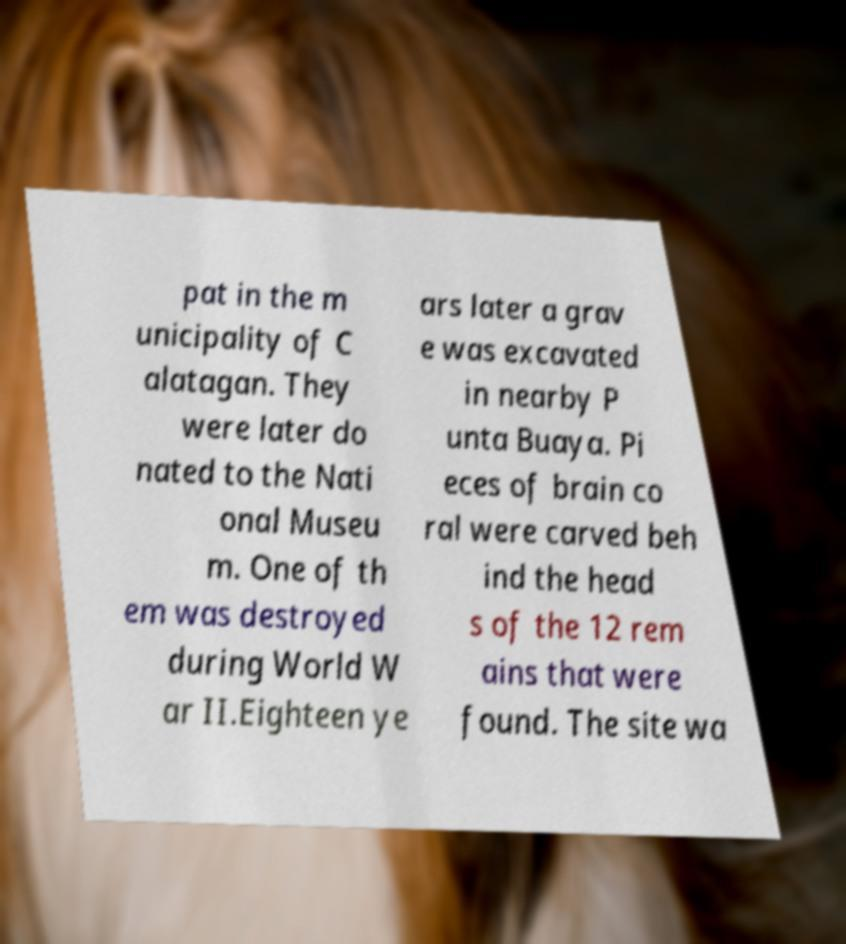For documentation purposes, I need the text within this image transcribed. Could you provide that? pat in the m unicipality of C alatagan. They were later do nated to the Nati onal Museu m. One of th em was destroyed during World W ar II.Eighteen ye ars later a grav e was excavated in nearby P unta Buaya. Pi eces of brain co ral were carved beh ind the head s of the 12 rem ains that were found. The site wa 